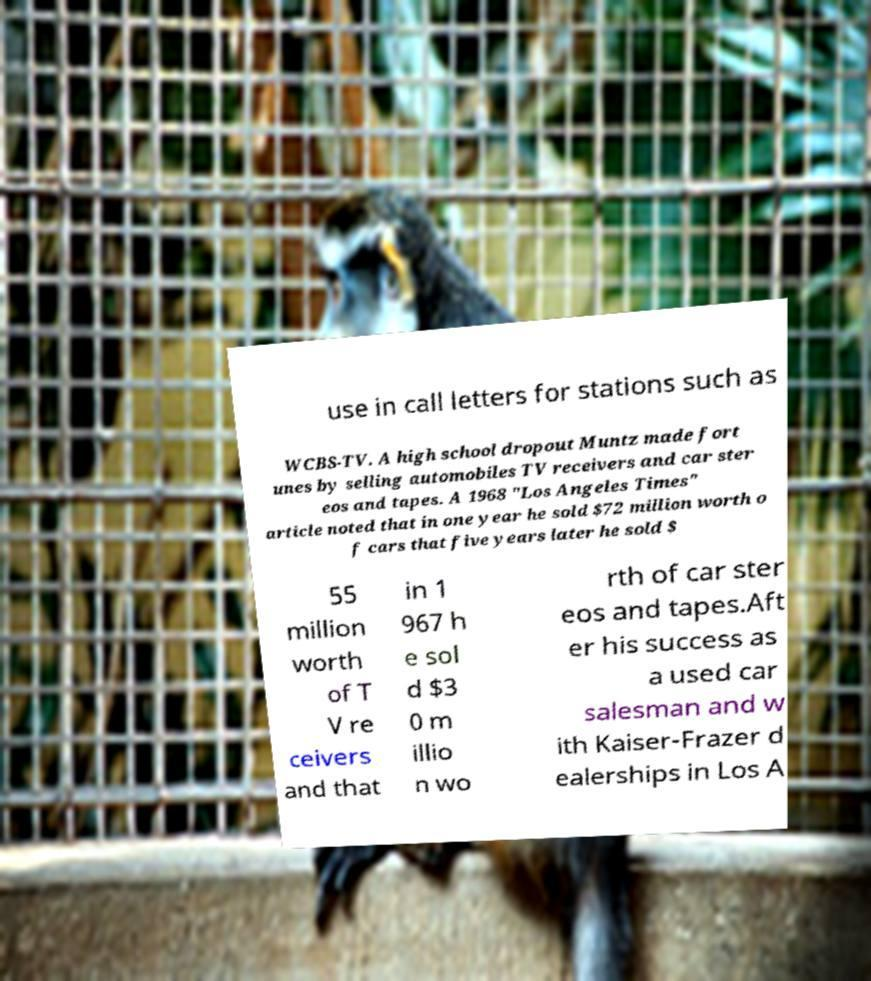Please read and relay the text visible in this image. What does it say? use in call letters for stations such as WCBS-TV. A high school dropout Muntz made fort unes by selling automobiles TV receivers and car ster eos and tapes. A 1968 "Los Angeles Times" article noted that in one year he sold $72 million worth o f cars that five years later he sold $ 55 million worth of T V re ceivers and that in 1 967 h e sol d $3 0 m illio n wo rth of car ster eos and tapes.Aft er his success as a used car salesman and w ith Kaiser-Frazer d ealerships in Los A 